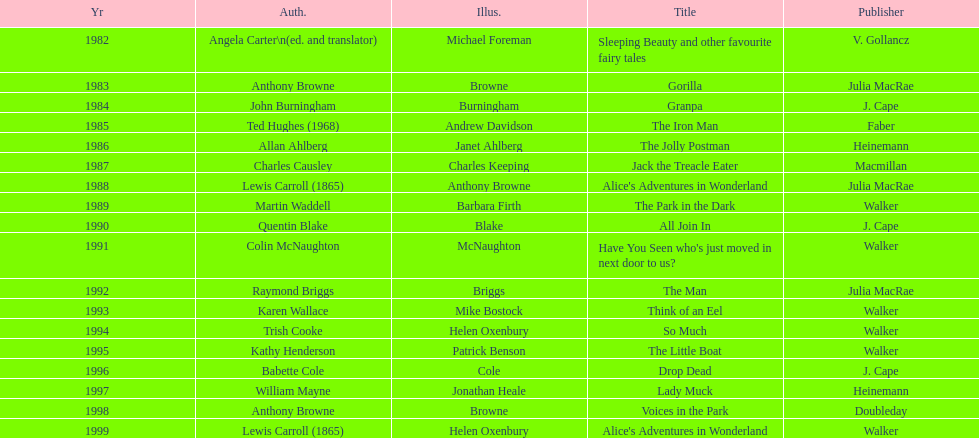How many titles had the same author listed as the illustrator? 7. Could you parse the entire table? {'header': ['Yr', 'Auth.', 'Illus.', 'Title', 'Publisher'], 'rows': [['1982', 'Angela Carter\\n(ed. and translator)', 'Michael Foreman', 'Sleeping Beauty and other favourite fairy tales', 'V. Gollancz'], ['1983', 'Anthony Browne', 'Browne', 'Gorilla', 'Julia MacRae'], ['1984', 'John Burningham', 'Burningham', 'Granpa', 'J. Cape'], ['1985', 'Ted Hughes (1968)', 'Andrew Davidson', 'The Iron Man', 'Faber'], ['1986', 'Allan Ahlberg', 'Janet Ahlberg', 'The Jolly Postman', 'Heinemann'], ['1987', 'Charles Causley', 'Charles Keeping', 'Jack the Treacle Eater', 'Macmillan'], ['1988', 'Lewis Carroll (1865)', 'Anthony Browne', "Alice's Adventures in Wonderland", 'Julia MacRae'], ['1989', 'Martin Waddell', 'Barbara Firth', 'The Park in the Dark', 'Walker'], ['1990', 'Quentin Blake', 'Blake', 'All Join In', 'J. Cape'], ['1991', 'Colin McNaughton', 'McNaughton', "Have You Seen who's just moved in next door to us?", 'Walker'], ['1992', 'Raymond Briggs', 'Briggs', 'The Man', 'Julia MacRae'], ['1993', 'Karen Wallace', 'Mike Bostock', 'Think of an Eel', 'Walker'], ['1994', 'Trish Cooke', 'Helen Oxenbury', 'So Much', 'Walker'], ['1995', 'Kathy Henderson', 'Patrick Benson', 'The Little Boat', 'Walker'], ['1996', 'Babette Cole', 'Cole', 'Drop Dead', 'J. Cape'], ['1997', 'William Mayne', 'Jonathan Heale', 'Lady Muck', 'Heinemann'], ['1998', 'Anthony Browne', 'Browne', 'Voices in the Park', 'Doubleday'], ['1999', 'Lewis Carroll (1865)', 'Helen Oxenbury', "Alice's Adventures in Wonderland", 'Walker']]} 